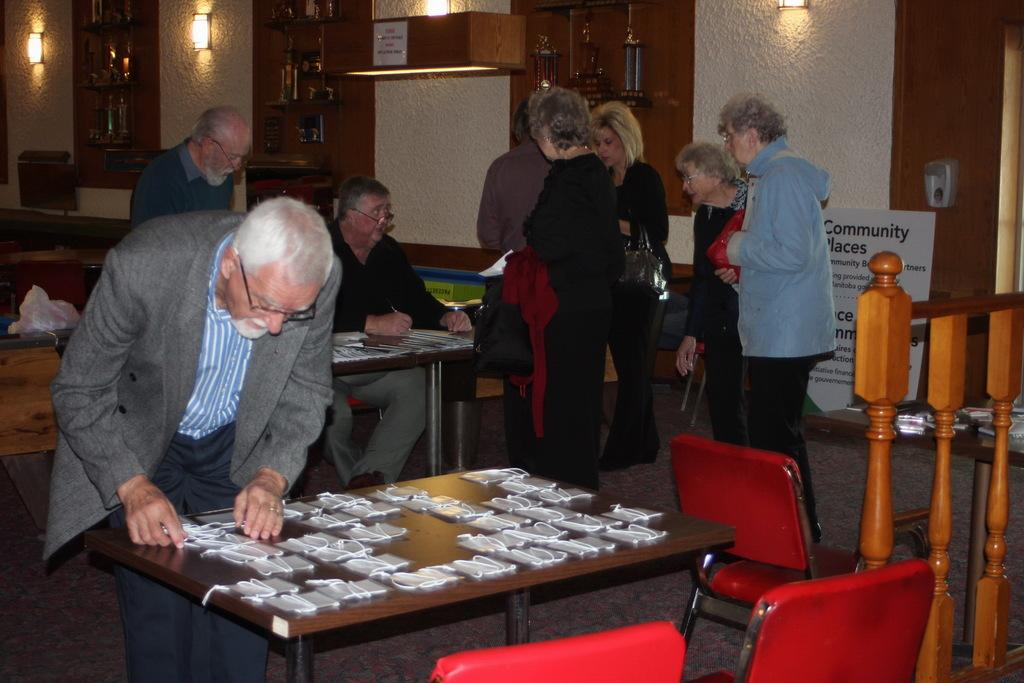How many persons are in the image? There is a group of persons in the image. What are the positions of the persons in the image? Some of the persons are sitting, and some are standing. What are the persons in the image doing? The persons in the image are doing some work. How many ducks are visible in the image? There are no ducks present in the image. What type of lizards can be seen interacting with the persons in the image? There are no lizards present in the image. 